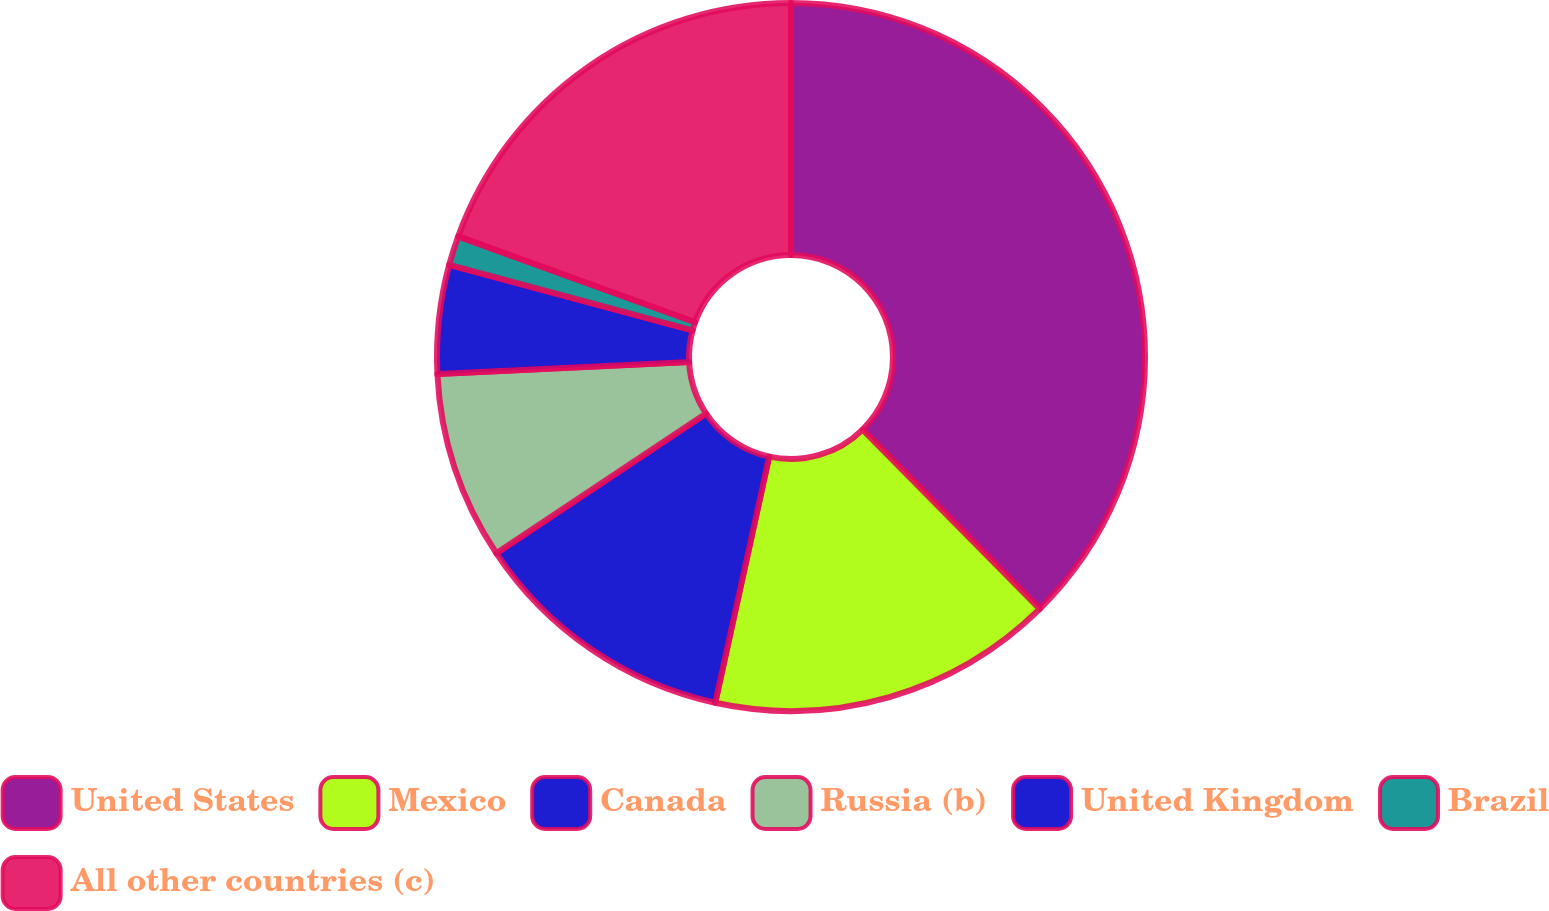Convert chart to OTSL. <chart><loc_0><loc_0><loc_500><loc_500><pie_chart><fcel>United States<fcel>Mexico<fcel>Canada<fcel>Russia (b)<fcel>United Kingdom<fcel>Brazil<fcel>All other countries (c)<nl><fcel>37.6%<fcel>15.84%<fcel>12.21%<fcel>8.59%<fcel>4.96%<fcel>1.34%<fcel>19.47%<nl></chart> 